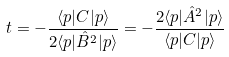Convert formula to latex. <formula><loc_0><loc_0><loc_500><loc_500>t = - \frac { \langle p | C | p \rangle } { 2 \langle p | \hat { B } ^ { 2 } | p \rangle } = - \frac { 2 \langle p | \hat { A } ^ { 2 } | p \rangle } { \langle p | C | p \rangle }</formula> 